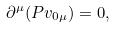Convert formula to latex. <formula><loc_0><loc_0><loc_500><loc_500>\partial ^ { \mu } ( P v _ { 0 \mu } ) = 0 ,</formula> 